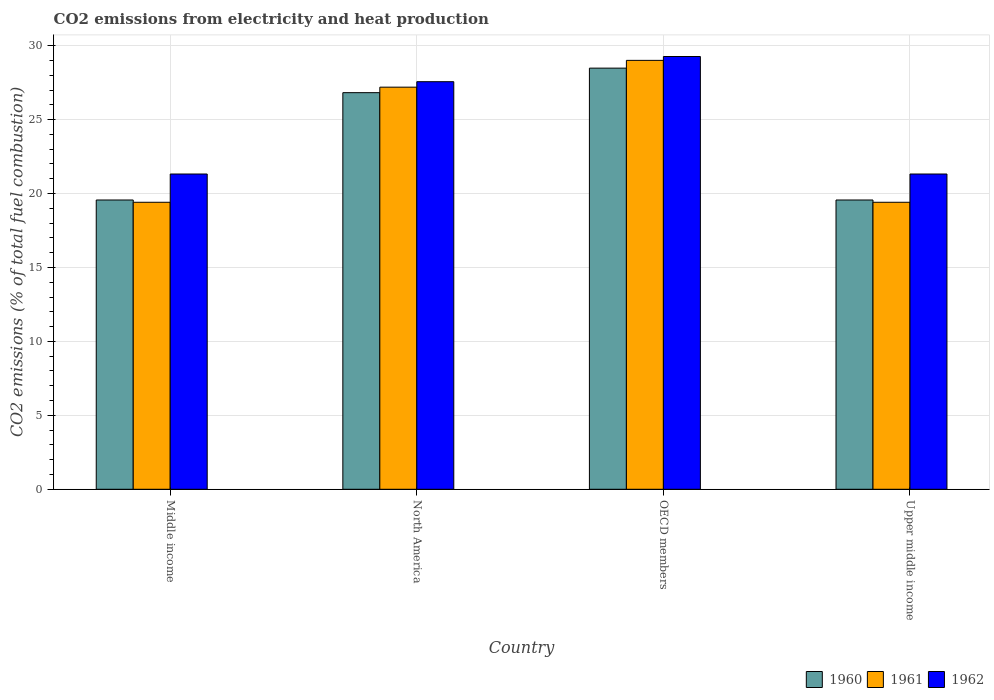Are the number of bars on each tick of the X-axis equal?
Offer a terse response. Yes. What is the label of the 4th group of bars from the left?
Offer a very short reply. Upper middle income. What is the amount of CO2 emitted in 1962 in OECD members?
Provide a succinct answer. 29.26. Across all countries, what is the maximum amount of CO2 emitted in 1960?
Your answer should be very brief. 28.48. Across all countries, what is the minimum amount of CO2 emitted in 1962?
Give a very brief answer. 21.32. In which country was the amount of CO2 emitted in 1962 maximum?
Make the answer very short. OECD members. In which country was the amount of CO2 emitted in 1960 minimum?
Provide a succinct answer. Middle income. What is the total amount of CO2 emitted in 1961 in the graph?
Offer a terse response. 95.01. What is the difference between the amount of CO2 emitted in 1960 in Middle income and that in North America?
Offer a very short reply. -7.26. What is the difference between the amount of CO2 emitted in 1960 in Middle income and the amount of CO2 emitted in 1962 in North America?
Your answer should be very brief. -8. What is the average amount of CO2 emitted in 1962 per country?
Offer a terse response. 24.87. What is the difference between the amount of CO2 emitted of/in 1961 and amount of CO2 emitted of/in 1960 in OECD members?
Keep it short and to the point. 0.52. In how many countries, is the amount of CO2 emitted in 1962 greater than 3 %?
Your answer should be compact. 4. What is the ratio of the amount of CO2 emitted in 1962 in North America to that in OECD members?
Offer a very short reply. 0.94. Is the amount of CO2 emitted in 1960 in OECD members less than that in Upper middle income?
Offer a terse response. No. Is the difference between the amount of CO2 emitted in 1961 in North America and OECD members greater than the difference between the amount of CO2 emitted in 1960 in North America and OECD members?
Offer a terse response. No. What is the difference between the highest and the second highest amount of CO2 emitted in 1961?
Give a very brief answer. -7.78. What is the difference between the highest and the lowest amount of CO2 emitted in 1960?
Ensure brevity in your answer.  8.92. In how many countries, is the amount of CO2 emitted in 1961 greater than the average amount of CO2 emitted in 1961 taken over all countries?
Offer a very short reply. 2. What does the 1st bar from the left in Upper middle income represents?
Offer a very short reply. 1960. Is it the case that in every country, the sum of the amount of CO2 emitted in 1961 and amount of CO2 emitted in 1960 is greater than the amount of CO2 emitted in 1962?
Offer a very short reply. Yes. How many bars are there?
Your response must be concise. 12. Are all the bars in the graph horizontal?
Provide a short and direct response. No. How many countries are there in the graph?
Keep it short and to the point. 4. What is the difference between two consecutive major ticks on the Y-axis?
Offer a very short reply. 5. Does the graph contain any zero values?
Your response must be concise. No. How are the legend labels stacked?
Offer a terse response. Horizontal. What is the title of the graph?
Offer a very short reply. CO2 emissions from electricity and heat production. Does "1992" appear as one of the legend labels in the graph?
Your answer should be very brief. No. What is the label or title of the Y-axis?
Make the answer very short. CO2 emissions (% of total fuel combustion). What is the CO2 emissions (% of total fuel combustion) in 1960 in Middle income?
Keep it short and to the point. 19.56. What is the CO2 emissions (% of total fuel combustion) of 1961 in Middle income?
Provide a succinct answer. 19.41. What is the CO2 emissions (% of total fuel combustion) of 1962 in Middle income?
Your answer should be very brief. 21.32. What is the CO2 emissions (% of total fuel combustion) of 1960 in North America?
Make the answer very short. 26.82. What is the CO2 emissions (% of total fuel combustion) of 1961 in North America?
Your answer should be compact. 27.19. What is the CO2 emissions (% of total fuel combustion) of 1962 in North America?
Provide a succinct answer. 27.56. What is the CO2 emissions (% of total fuel combustion) in 1960 in OECD members?
Ensure brevity in your answer.  28.48. What is the CO2 emissions (% of total fuel combustion) in 1961 in OECD members?
Give a very brief answer. 29. What is the CO2 emissions (% of total fuel combustion) in 1962 in OECD members?
Provide a succinct answer. 29.26. What is the CO2 emissions (% of total fuel combustion) in 1960 in Upper middle income?
Give a very brief answer. 19.56. What is the CO2 emissions (% of total fuel combustion) in 1961 in Upper middle income?
Offer a terse response. 19.41. What is the CO2 emissions (% of total fuel combustion) of 1962 in Upper middle income?
Provide a succinct answer. 21.32. Across all countries, what is the maximum CO2 emissions (% of total fuel combustion) in 1960?
Provide a short and direct response. 28.48. Across all countries, what is the maximum CO2 emissions (% of total fuel combustion) of 1961?
Offer a terse response. 29. Across all countries, what is the maximum CO2 emissions (% of total fuel combustion) of 1962?
Your response must be concise. 29.26. Across all countries, what is the minimum CO2 emissions (% of total fuel combustion) of 1960?
Offer a terse response. 19.56. Across all countries, what is the minimum CO2 emissions (% of total fuel combustion) in 1961?
Ensure brevity in your answer.  19.41. Across all countries, what is the minimum CO2 emissions (% of total fuel combustion) of 1962?
Your response must be concise. 21.32. What is the total CO2 emissions (% of total fuel combustion) in 1960 in the graph?
Offer a terse response. 94.42. What is the total CO2 emissions (% of total fuel combustion) of 1961 in the graph?
Keep it short and to the point. 95.01. What is the total CO2 emissions (% of total fuel combustion) in 1962 in the graph?
Provide a succinct answer. 99.47. What is the difference between the CO2 emissions (% of total fuel combustion) of 1960 in Middle income and that in North America?
Ensure brevity in your answer.  -7.26. What is the difference between the CO2 emissions (% of total fuel combustion) in 1961 in Middle income and that in North America?
Give a very brief answer. -7.78. What is the difference between the CO2 emissions (% of total fuel combustion) of 1962 in Middle income and that in North America?
Make the answer very short. -6.24. What is the difference between the CO2 emissions (% of total fuel combustion) in 1960 in Middle income and that in OECD members?
Offer a very short reply. -8.92. What is the difference between the CO2 emissions (% of total fuel combustion) of 1961 in Middle income and that in OECD members?
Your answer should be compact. -9.6. What is the difference between the CO2 emissions (% of total fuel combustion) in 1962 in Middle income and that in OECD members?
Ensure brevity in your answer.  -7.95. What is the difference between the CO2 emissions (% of total fuel combustion) in 1961 in Middle income and that in Upper middle income?
Provide a succinct answer. 0. What is the difference between the CO2 emissions (% of total fuel combustion) of 1960 in North America and that in OECD members?
Keep it short and to the point. -1.66. What is the difference between the CO2 emissions (% of total fuel combustion) in 1961 in North America and that in OECD members?
Your response must be concise. -1.81. What is the difference between the CO2 emissions (% of total fuel combustion) in 1962 in North America and that in OECD members?
Offer a very short reply. -1.7. What is the difference between the CO2 emissions (% of total fuel combustion) in 1960 in North America and that in Upper middle income?
Your answer should be compact. 7.26. What is the difference between the CO2 emissions (% of total fuel combustion) in 1961 in North America and that in Upper middle income?
Make the answer very short. 7.78. What is the difference between the CO2 emissions (% of total fuel combustion) in 1962 in North America and that in Upper middle income?
Provide a succinct answer. 6.24. What is the difference between the CO2 emissions (% of total fuel combustion) in 1960 in OECD members and that in Upper middle income?
Your answer should be very brief. 8.92. What is the difference between the CO2 emissions (% of total fuel combustion) of 1961 in OECD members and that in Upper middle income?
Keep it short and to the point. 9.6. What is the difference between the CO2 emissions (% of total fuel combustion) in 1962 in OECD members and that in Upper middle income?
Offer a terse response. 7.95. What is the difference between the CO2 emissions (% of total fuel combustion) of 1960 in Middle income and the CO2 emissions (% of total fuel combustion) of 1961 in North America?
Offer a terse response. -7.63. What is the difference between the CO2 emissions (% of total fuel combustion) of 1960 in Middle income and the CO2 emissions (% of total fuel combustion) of 1962 in North America?
Offer a very short reply. -8. What is the difference between the CO2 emissions (% of total fuel combustion) in 1961 in Middle income and the CO2 emissions (% of total fuel combustion) in 1962 in North America?
Provide a succinct answer. -8.15. What is the difference between the CO2 emissions (% of total fuel combustion) of 1960 in Middle income and the CO2 emissions (% of total fuel combustion) of 1961 in OECD members?
Ensure brevity in your answer.  -9.44. What is the difference between the CO2 emissions (% of total fuel combustion) of 1960 in Middle income and the CO2 emissions (% of total fuel combustion) of 1962 in OECD members?
Your response must be concise. -9.7. What is the difference between the CO2 emissions (% of total fuel combustion) in 1961 in Middle income and the CO2 emissions (% of total fuel combustion) in 1962 in OECD members?
Give a very brief answer. -9.86. What is the difference between the CO2 emissions (% of total fuel combustion) in 1960 in Middle income and the CO2 emissions (% of total fuel combustion) in 1961 in Upper middle income?
Ensure brevity in your answer.  0.15. What is the difference between the CO2 emissions (% of total fuel combustion) of 1960 in Middle income and the CO2 emissions (% of total fuel combustion) of 1962 in Upper middle income?
Ensure brevity in your answer.  -1.76. What is the difference between the CO2 emissions (% of total fuel combustion) in 1961 in Middle income and the CO2 emissions (% of total fuel combustion) in 1962 in Upper middle income?
Your answer should be compact. -1.91. What is the difference between the CO2 emissions (% of total fuel combustion) in 1960 in North America and the CO2 emissions (% of total fuel combustion) in 1961 in OECD members?
Provide a succinct answer. -2.18. What is the difference between the CO2 emissions (% of total fuel combustion) of 1960 in North America and the CO2 emissions (% of total fuel combustion) of 1962 in OECD members?
Your answer should be compact. -2.44. What is the difference between the CO2 emissions (% of total fuel combustion) of 1961 in North America and the CO2 emissions (% of total fuel combustion) of 1962 in OECD members?
Offer a very short reply. -2.07. What is the difference between the CO2 emissions (% of total fuel combustion) in 1960 in North America and the CO2 emissions (% of total fuel combustion) in 1961 in Upper middle income?
Make the answer very short. 7.41. What is the difference between the CO2 emissions (% of total fuel combustion) in 1960 in North America and the CO2 emissions (% of total fuel combustion) in 1962 in Upper middle income?
Keep it short and to the point. 5.5. What is the difference between the CO2 emissions (% of total fuel combustion) of 1961 in North America and the CO2 emissions (% of total fuel combustion) of 1962 in Upper middle income?
Keep it short and to the point. 5.87. What is the difference between the CO2 emissions (% of total fuel combustion) in 1960 in OECD members and the CO2 emissions (% of total fuel combustion) in 1961 in Upper middle income?
Make the answer very short. 9.07. What is the difference between the CO2 emissions (% of total fuel combustion) in 1960 in OECD members and the CO2 emissions (% of total fuel combustion) in 1962 in Upper middle income?
Provide a short and direct response. 7.16. What is the difference between the CO2 emissions (% of total fuel combustion) of 1961 in OECD members and the CO2 emissions (% of total fuel combustion) of 1962 in Upper middle income?
Give a very brief answer. 7.68. What is the average CO2 emissions (% of total fuel combustion) in 1960 per country?
Make the answer very short. 23.61. What is the average CO2 emissions (% of total fuel combustion) in 1961 per country?
Ensure brevity in your answer.  23.75. What is the average CO2 emissions (% of total fuel combustion) of 1962 per country?
Provide a succinct answer. 24.87. What is the difference between the CO2 emissions (% of total fuel combustion) in 1960 and CO2 emissions (% of total fuel combustion) in 1961 in Middle income?
Offer a terse response. 0.15. What is the difference between the CO2 emissions (% of total fuel combustion) of 1960 and CO2 emissions (% of total fuel combustion) of 1962 in Middle income?
Provide a short and direct response. -1.76. What is the difference between the CO2 emissions (% of total fuel combustion) of 1961 and CO2 emissions (% of total fuel combustion) of 1962 in Middle income?
Offer a terse response. -1.91. What is the difference between the CO2 emissions (% of total fuel combustion) of 1960 and CO2 emissions (% of total fuel combustion) of 1961 in North America?
Offer a terse response. -0.37. What is the difference between the CO2 emissions (% of total fuel combustion) of 1960 and CO2 emissions (% of total fuel combustion) of 1962 in North America?
Your answer should be very brief. -0.74. What is the difference between the CO2 emissions (% of total fuel combustion) in 1961 and CO2 emissions (% of total fuel combustion) in 1962 in North America?
Offer a very short reply. -0.37. What is the difference between the CO2 emissions (% of total fuel combustion) of 1960 and CO2 emissions (% of total fuel combustion) of 1961 in OECD members?
Keep it short and to the point. -0.52. What is the difference between the CO2 emissions (% of total fuel combustion) in 1960 and CO2 emissions (% of total fuel combustion) in 1962 in OECD members?
Offer a terse response. -0.79. What is the difference between the CO2 emissions (% of total fuel combustion) of 1961 and CO2 emissions (% of total fuel combustion) of 1962 in OECD members?
Your answer should be very brief. -0.26. What is the difference between the CO2 emissions (% of total fuel combustion) of 1960 and CO2 emissions (% of total fuel combustion) of 1961 in Upper middle income?
Your answer should be compact. 0.15. What is the difference between the CO2 emissions (% of total fuel combustion) in 1960 and CO2 emissions (% of total fuel combustion) in 1962 in Upper middle income?
Make the answer very short. -1.76. What is the difference between the CO2 emissions (% of total fuel combustion) in 1961 and CO2 emissions (% of total fuel combustion) in 1962 in Upper middle income?
Make the answer very short. -1.91. What is the ratio of the CO2 emissions (% of total fuel combustion) in 1960 in Middle income to that in North America?
Make the answer very short. 0.73. What is the ratio of the CO2 emissions (% of total fuel combustion) of 1961 in Middle income to that in North America?
Keep it short and to the point. 0.71. What is the ratio of the CO2 emissions (% of total fuel combustion) in 1962 in Middle income to that in North America?
Provide a short and direct response. 0.77. What is the ratio of the CO2 emissions (% of total fuel combustion) in 1960 in Middle income to that in OECD members?
Offer a terse response. 0.69. What is the ratio of the CO2 emissions (% of total fuel combustion) in 1961 in Middle income to that in OECD members?
Provide a short and direct response. 0.67. What is the ratio of the CO2 emissions (% of total fuel combustion) of 1962 in Middle income to that in OECD members?
Offer a very short reply. 0.73. What is the ratio of the CO2 emissions (% of total fuel combustion) of 1960 in Middle income to that in Upper middle income?
Offer a terse response. 1. What is the ratio of the CO2 emissions (% of total fuel combustion) in 1961 in Middle income to that in Upper middle income?
Your answer should be very brief. 1. What is the ratio of the CO2 emissions (% of total fuel combustion) of 1960 in North America to that in OECD members?
Ensure brevity in your answer.  0.94. What is the ratio of the CO2 emissions (% of total fuel combustion) of 1962 in North America to that in OECD members?
Offer a very short reply. 0.94. What is the ratio of the CO2 emissions (% of total fuel combustion) in 1960 in North America to that in Upper middle income?
Your answer should be compact. 1.37. What is the ratio of the CO2 emissions (% of total fuel combustion) in 1961 in North America to that in Upper middle income?
Provide a succinct answer. 1.4. What is the ratio of the CO2 emissions (% of total fuel combustion) in 1962 in North America to that in Upper middle income?
Provide a short and direct response. 1.29. What is the ratio of the CO2 emissions (% of total fuel combustion) in 1960 in OECD members to that in Upper middle income?
Your answer should be very brief. 1.46. What is the ratio of the CO2 emissions (% of total fuel combustion) of 1961 in OECD members to that in Upper middle income?
Your answer should be very brief. 1.49. What is the ratio of the CO2 emissions (% of total fuel combustion) in 1962 in OECD members to that in Upper middle income?
Keep it short and to the point. 1.37. What is the difference between the highest and the second highest CO2 emissions (% of total fuel combustion) of 1960?
Your response must be concise. 1.66. What is the difference between the highest and the second highest CO2 emissions (% of total fuel combustion) in 1961?
Provide a short and direct response. 1.81. What is the difference between the highest and the second highest CO2 emissions (% of total fuel combustion) in 1962?
Your answer should be compact. 1.7. What is the difference between the highest and the lowest CO2 emissions (% of total fuel combustion) of 1960?
Offer a terse response. 8.92. What is the difference between the highest and the lowest CO2 emissions (% of total fuel combustion) of 1961?
Keep it short and to the point. 9.6. What is the difference between the highest and the lowest CO2 emissions (% of total fuel combustion) in 1962?
Your response must be concise. 7.95. 